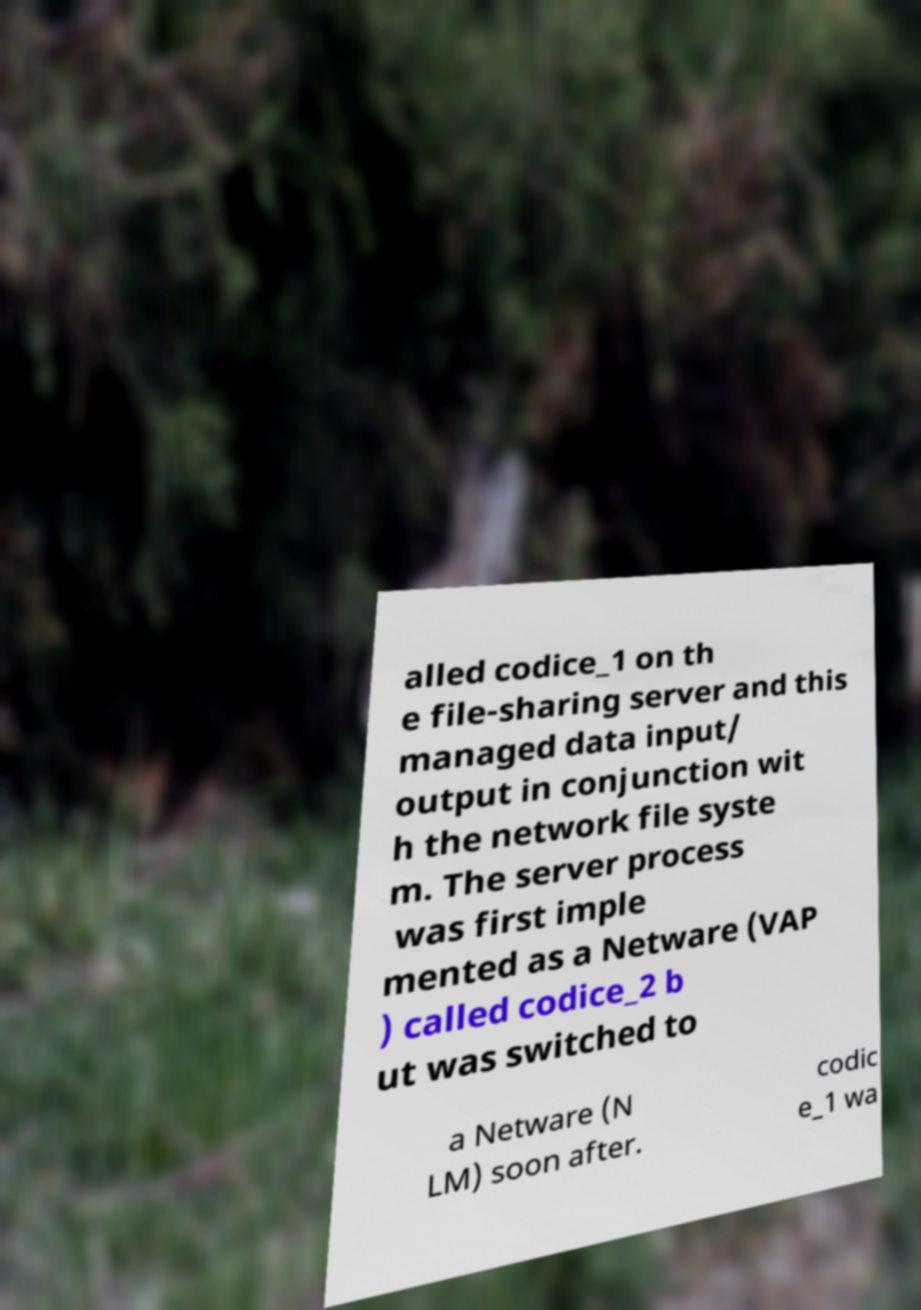Please read and relay the text visible in this image. What does it say? alled codice_1 on th e file-sharing server and this managed data input/ output in conjunction wit h the network file syste m. The server process was first imple mented as a Netware (VAP ) called codice_2 b ut was switched to a Netware (N LM) soon after. codic e_1 wa 